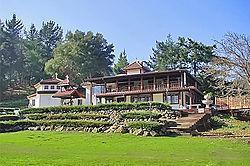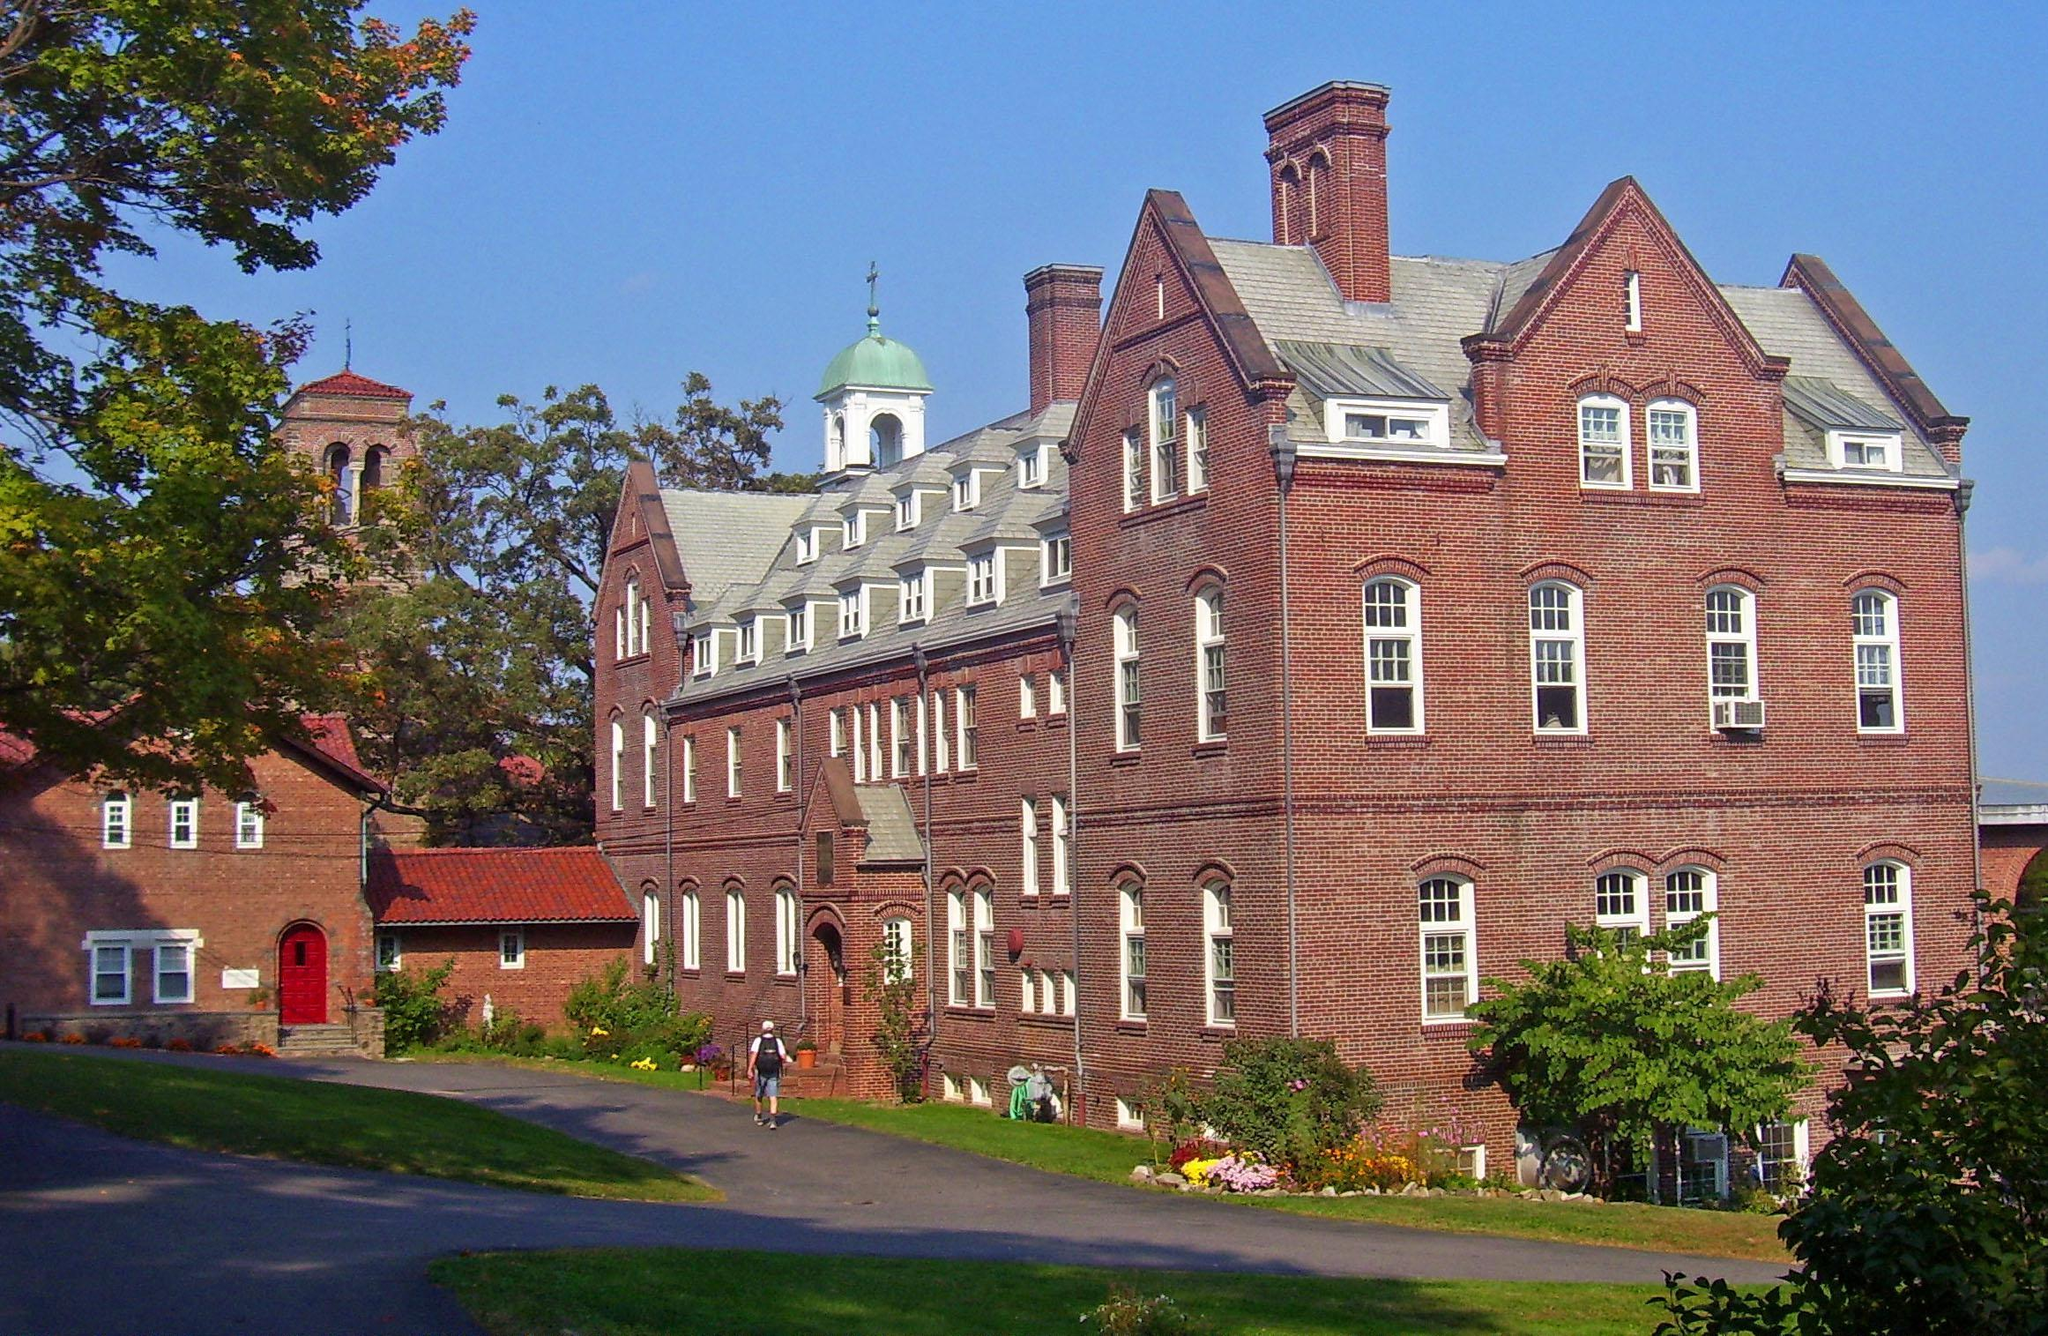The first image is the image on the left, the second image is the image on the right. Considering the images on both sides, is "The wooden sign is for a monastary." valid? Answer yes or no. No. 